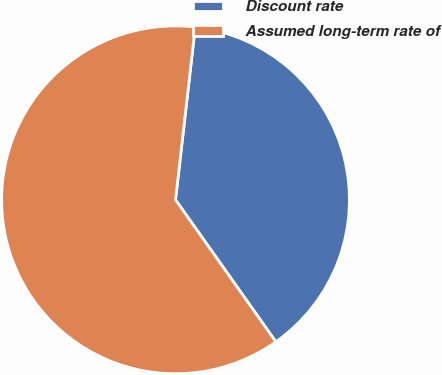<chart> <loc_0><loc_0><loc_500><loc_500><pie_chart><fcel>Discount rate<fcel>Assumed long-term rate of<nl><fcel>38.4%<fcel>61.6%<nl></chart> 